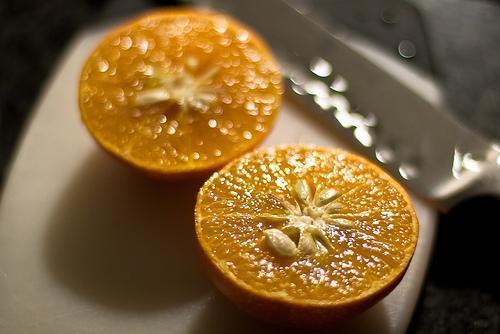How many cuts were made by the knife?
Give a very brief answer. 1. How many pieces are on the plate?
Give a very brief answer. 2. 